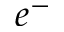<formula> <loc_0><loc_0><loc_500><loc_500>e ^ { - }</formula> 